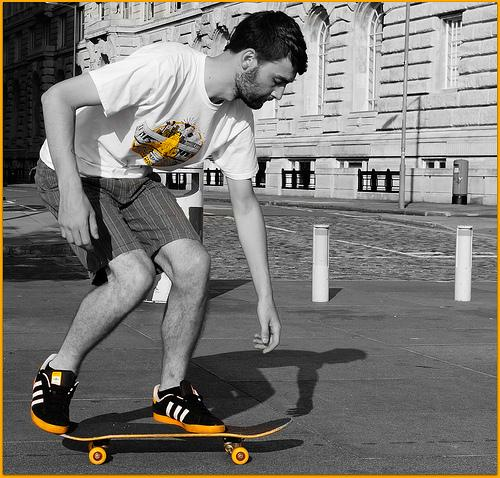In the image, what type of clothes is the man wearing? The man is wearing a white t-shirt with a yellow and grey logo, plaid shorts, and black sneakers with white stripes and orange accents. What is the state of the man's legs in the image, and how is it affecting his overall appearance? The man's legs are hairy, making him appear more rugged and outdoorsy. How can the man's emotion be inferred from the image? The man is enjoying his day and getting some exercise while skateboarding, implying he might be feeling happy and energetic. What is an architectural feature of the building that is visible in the image? Arched windows are an architectural feature of the building visible in the image. What are some noticeable colors present on the man's outfit and skateboard? Orange accents on sneakers and skateboard, yellow and grey logo on a white t-shirt, and black sneakers with white stripes. Describe the types of windows on the building in the image. The building has arched windows and rectangular small-paned windows. What is the man's outdoor activity in the image? The man is skateboarding on the sidewalk. How many wheels are visible on the skateboard and what is their color? There are two orange wheels visible on the skateboard. What kind of recreational activity is the man participating in during the daytime? The man is participating in skateboarding as a recreational activity. Identify the main object in the scene and describe its position relative to the other objects. The main object is a man on a skateboard who is positioned in the foreground with the sidewalk, building, and street in the background. Describe the human figure's overall activity in this scene. The man is skateboarding and seemingly preparing to do a trick Which part of a man can be recognized in the image? Ear and hand of the man are recognizable Narrate the scene with the man and the skateboard. The man is happily skateboarding outside during the day while performing a trick or maneuver Where is the red fire hydrant situated behind the skateboarder? Spot the red fire hydrant in the background, right behind the skateboarder. Identify the pink umbrella held by a person watching the skateboarder from afar. A person holding a bright pink umbrella is standing in the background, observing the skateboarder's actions. Describe the design element/detail found on the man's t-shirt. There is a yellow and gray logo on the white tee shirt Are there any other objects which seem to be preventing through traffic in the background? Mention their features. Yes, there are posts in the background that appear to be preventing through traffic. Describe the orange accents in the image. Orange enhancements are present on the skateboard wheel, trim of shoes, and a logo on the shirt. Provide the description of the skateboarder's shorts. The skateboarder is wearing striped shorts Could you please point out the flying green kite in the sky? There is a green kite soaring in the sky above the skateboarder. What surface is the man skateboarding on? The man is skateboarding on the sidewalk What does the man seem to be enjoying? The man seems to be enjoying some recreation and exercise on his skateboard What type of windows can be seen on the building in the image? Rectangular small paned window and arched windows What style of photo is the image? Black and white photo with orange enhanced Can you locate the vintage blue car parked in the background of the image? There's a vintage blue car parked on the side, giving the scene a retro feel. Do you see the billboard with the skater's image promoting a film just beside him? The advertisement of an upcoming movie featuring the skateboarder is displayed on a billboard next to him. What is the design on the skateboard wheels? The design on the skateboard wheels is orange Explain the event taking place in the image. A man skateboarding, performing a trick or maneuver What color are the wheels on the surfboard in the image? Yellow Can you find the fluffy blue dog playing with its toy next to the skateboarder? There's a fluffy blue dog happily playing with a ball in the background. Choose the correct statement regarding the skateboarder's sneakers: A) Black with white strips B) White with orange trim C) Blue with yellow accents A) Black with white strips Identify the type of pole present in the image. A light pole Is there any structure to keep a building intact in the image? If yes, provide the details. There is a keystone over a building in the image Is a trash receptacle visible in the scene? If so, describe its location. Yes, a trash receptacle is visible behind the skateboarder. What type of railings can be seen in the image? Wrought iron railings 